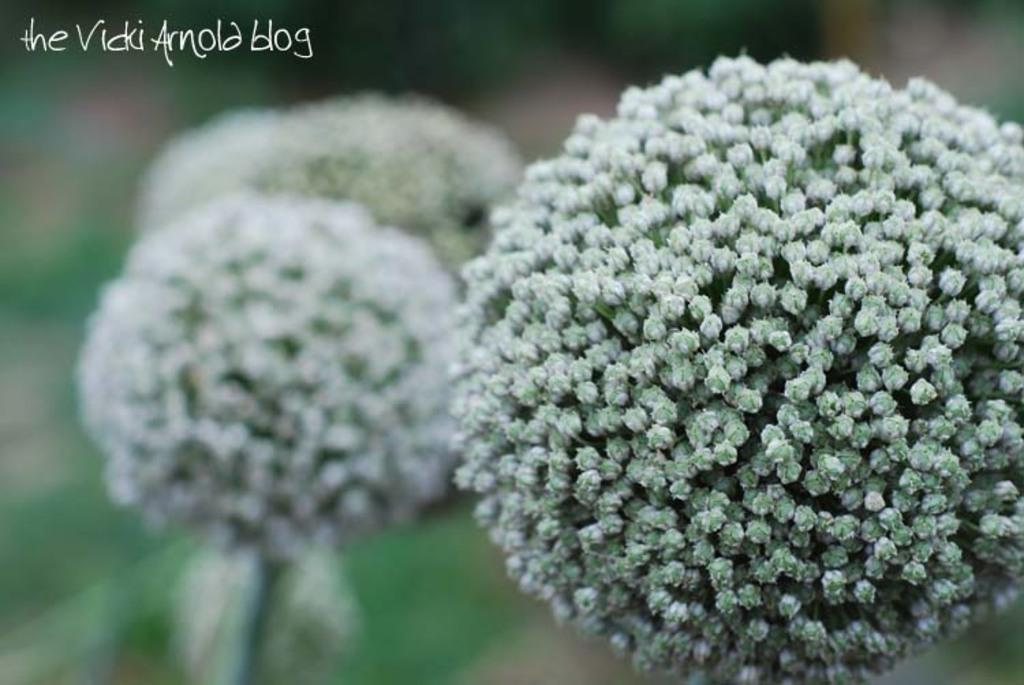What type of living organisms can be seen in the image? There are flowers in the image. Can you describe the background of the image? The background of the image is blurred. What theory is the stranger discussing with the flowers in the image? There is no stranger present in the image, and therefore no discussion or theory can be observed. 